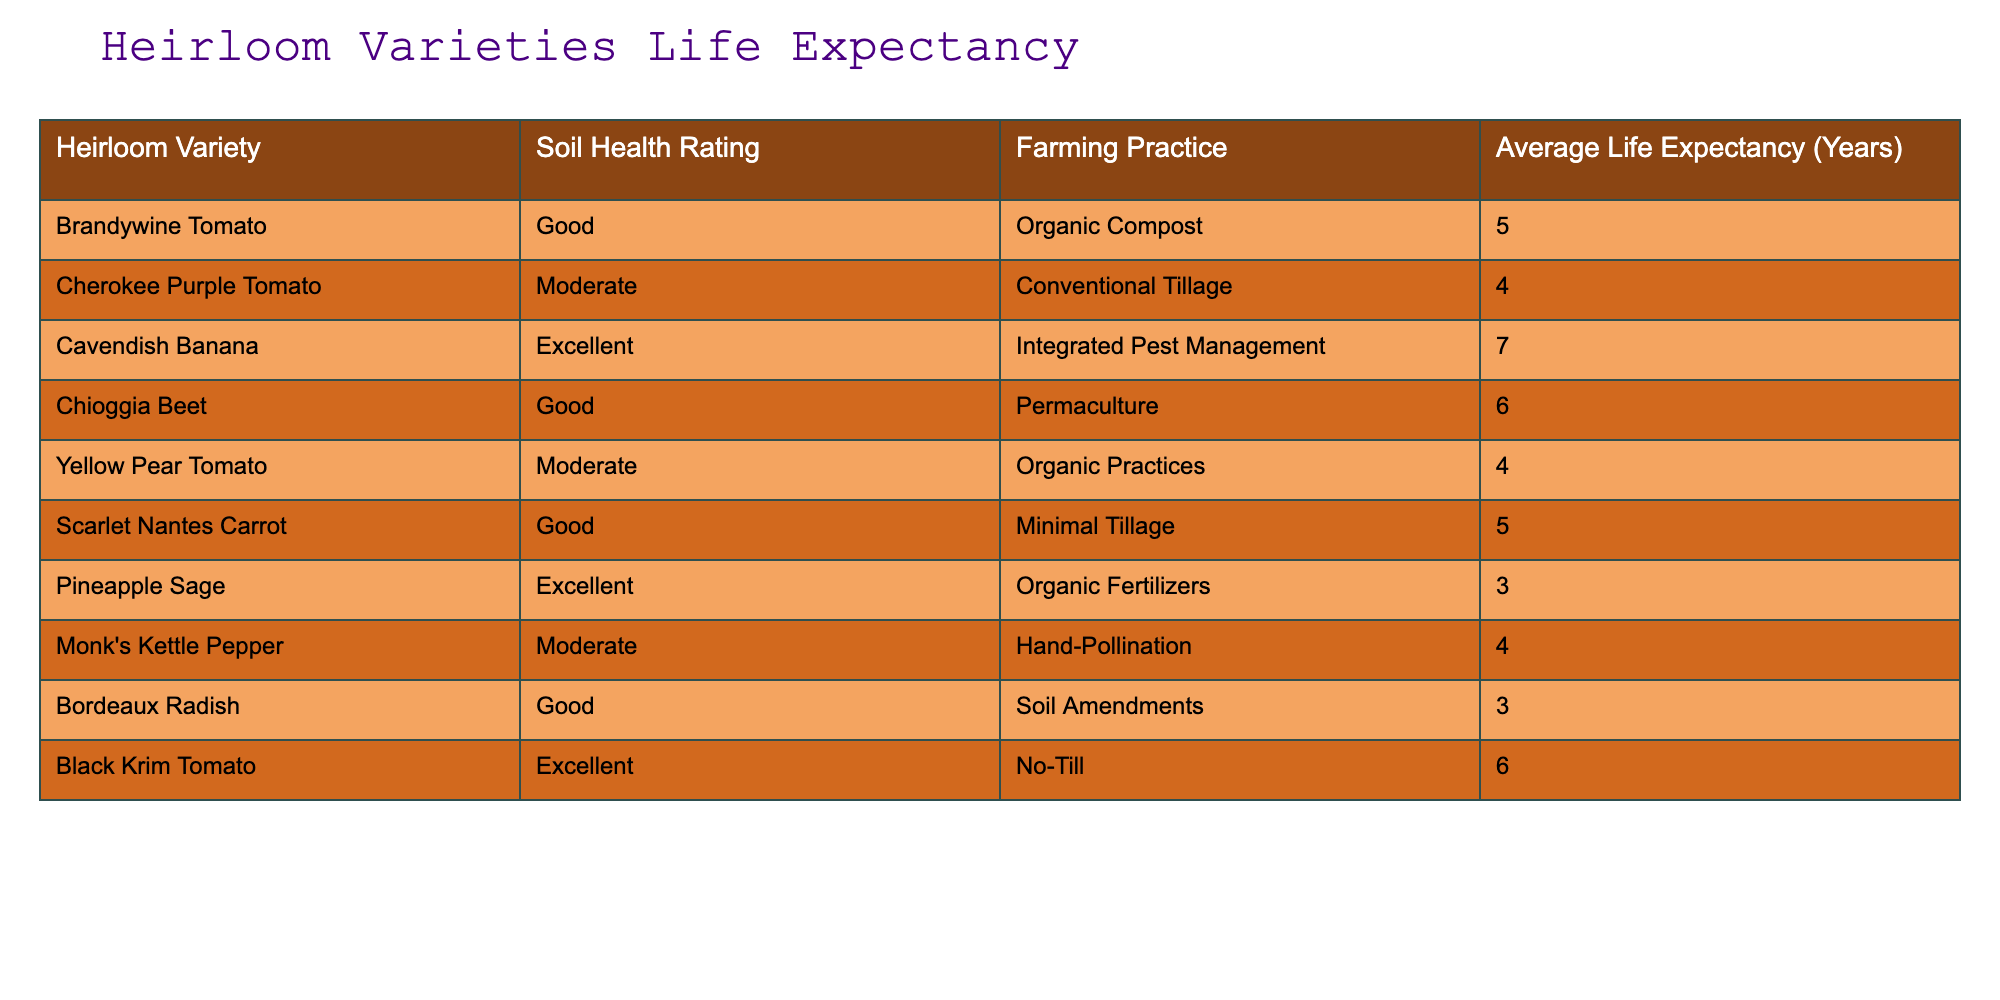What is the average life expectancy of the Brandywine Tomato? The life expectancy of the Brandywine Tomato is listed directly in the table as 5 years.
Answer: 5 years Which heirloom variety has the longest average life expectancy? The Cavendish Banana has the longest average life expectancy at 7 years, as it's the highest value in the Average Life Expectancy column.
Answer: Cavendish Banana How many heirloom varieties have an average life expectancy of 4 years? The table lists three varieties with an average life expectancy of 4 years: Cherokee Purple Tomato, Yellow Pear Tomato, and Monk's Kettle Pepper. Therefore, the count is 3.
Answer: 3 Is it true that all heirloom varieties with excellent soil health have a life expectancy greater than 4 years? There are two varieties with excellent soil health: Cavendish Banana (7 years) and Pineapple Sage (3 years). Since Pineapple Sage is 3 years, the statement is false.
Answer: No What is the average life expectancy of heirloom varieties that use organic practices? The heirloom varieties using organic practices (such as Organic Compost, Organic Practices, and Organic Fertilizers) have expectancies of 5, 4, and 3 years respectively. The average is (5 + 4 + 3) / 3 = 12 / 3 = 4 years.
Answer: 4 years Which farming practice has the highest average life expectancy across heirloom varieties? The table does not explicitly state averages per farming practice, but by checking the life expectancies for each practice: Organic Compost (5), Conventional Tillage (4), Integrated Pest Management (7), Permaculture (6), Organic Practices (4), Minimal Tillage (5), Hand-Pollination (4), and Soil Amendments (3). The highest is Integrated Pest Management with 7 years.
Answer: Integrated Pest Management How does the average life expectancy of heirloom varieties rated as good compare to those rated as moderate? The varieties rated as good have average expectancies of 5 years (Brandywine Tomato), 6 years (Chioggia Beet), and 5 years (Scarlet Nantes Carrot), giving an average of (5 + 6 + 5) / 3 = 16 / 3 = approximately 5.33. The moderate varieties (Cherokee Purple Tomato, Yellow Pear Tomato, and Monk's Kettle Pepper) average (4 + 4 + 4) / 3 = 12 / 3 = 4 years. Therefore, good soil health varieties average approximately 5.33 years, while moderate varieties average 4 years.
Answer: Good: 5.33 years, Moderate: 4 years Are there any heirloom varieties with a good soil health rating that use minimal tillage? Yes, the Scarlet Nantes Carrot has a good soil health rating and uses minimal tillage; therefore, the answer is yes.
Answer: Yes 